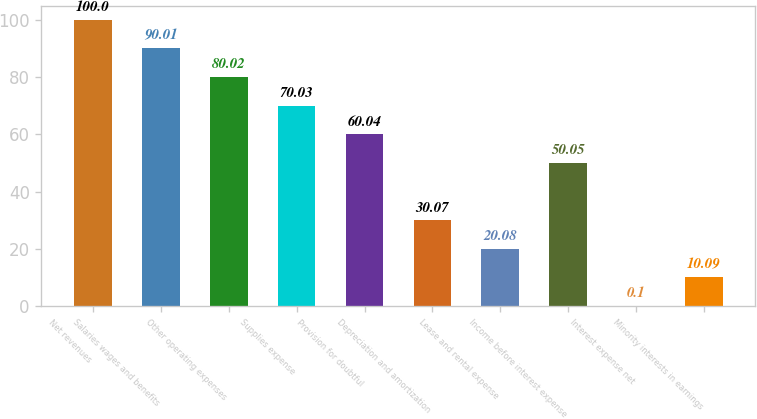<chart> <loc_0><loc_0><loc_500><loc_500><bar_chart><fcel>Net revenues<fcel>Salaries wages and benefits<fcel>Other operating expenses<fcel>Supplies expense<fcel>Provision for doubtful<fcel>Depreciation and amortization<fcel>Lease and rental expense<fcel>Income before interest expense<fcel>Interest expense net<fcel>Minority interests in earnings<nl><fcel>100<fcel>90.01<fcel>80.02<fcel>70.03<fcel>60.04<fcel>30.07<fcel>20.08<fcel>50.05<fcel>0.1<fcel>10.09<nl></chart> 